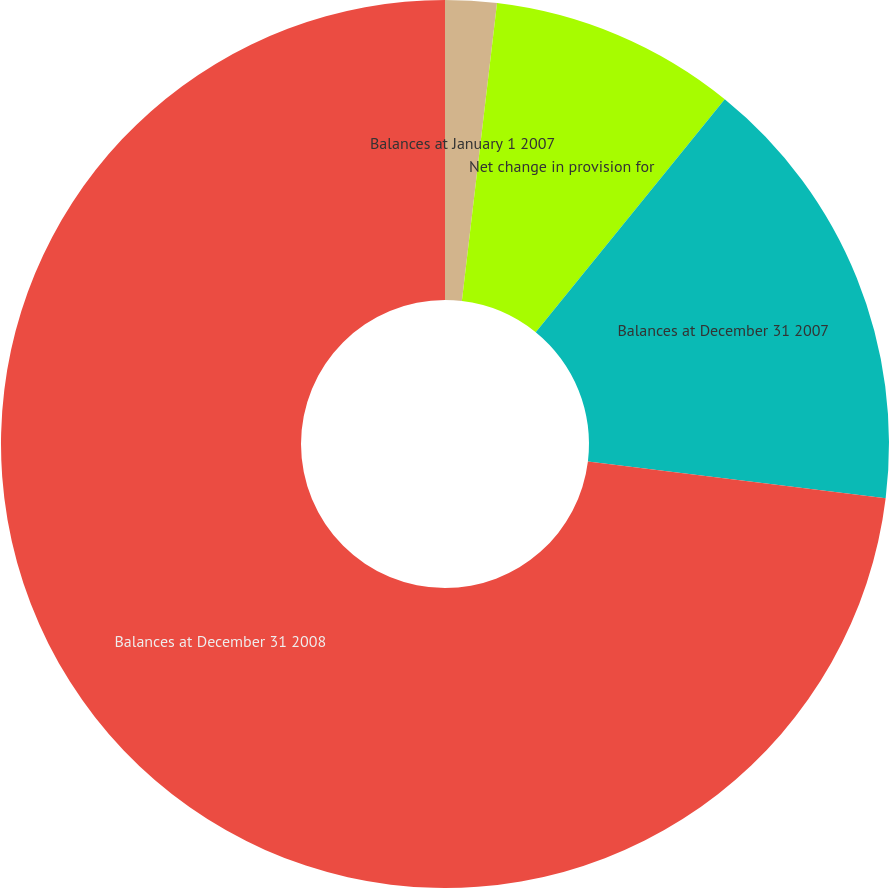Convert chart. <chart><loc_0><loc_0><loc_500><loc_500><pie_chart><fcel>Balances at January 1 2007<fcel>Net change in provision for<fcel>Balances at December 31 2007<fcel>Balances at December 31 2008<nl><fcel>1.87%<fcel>8.98%<fcel>16.1%<fcel>73.05%<nl></chart> 